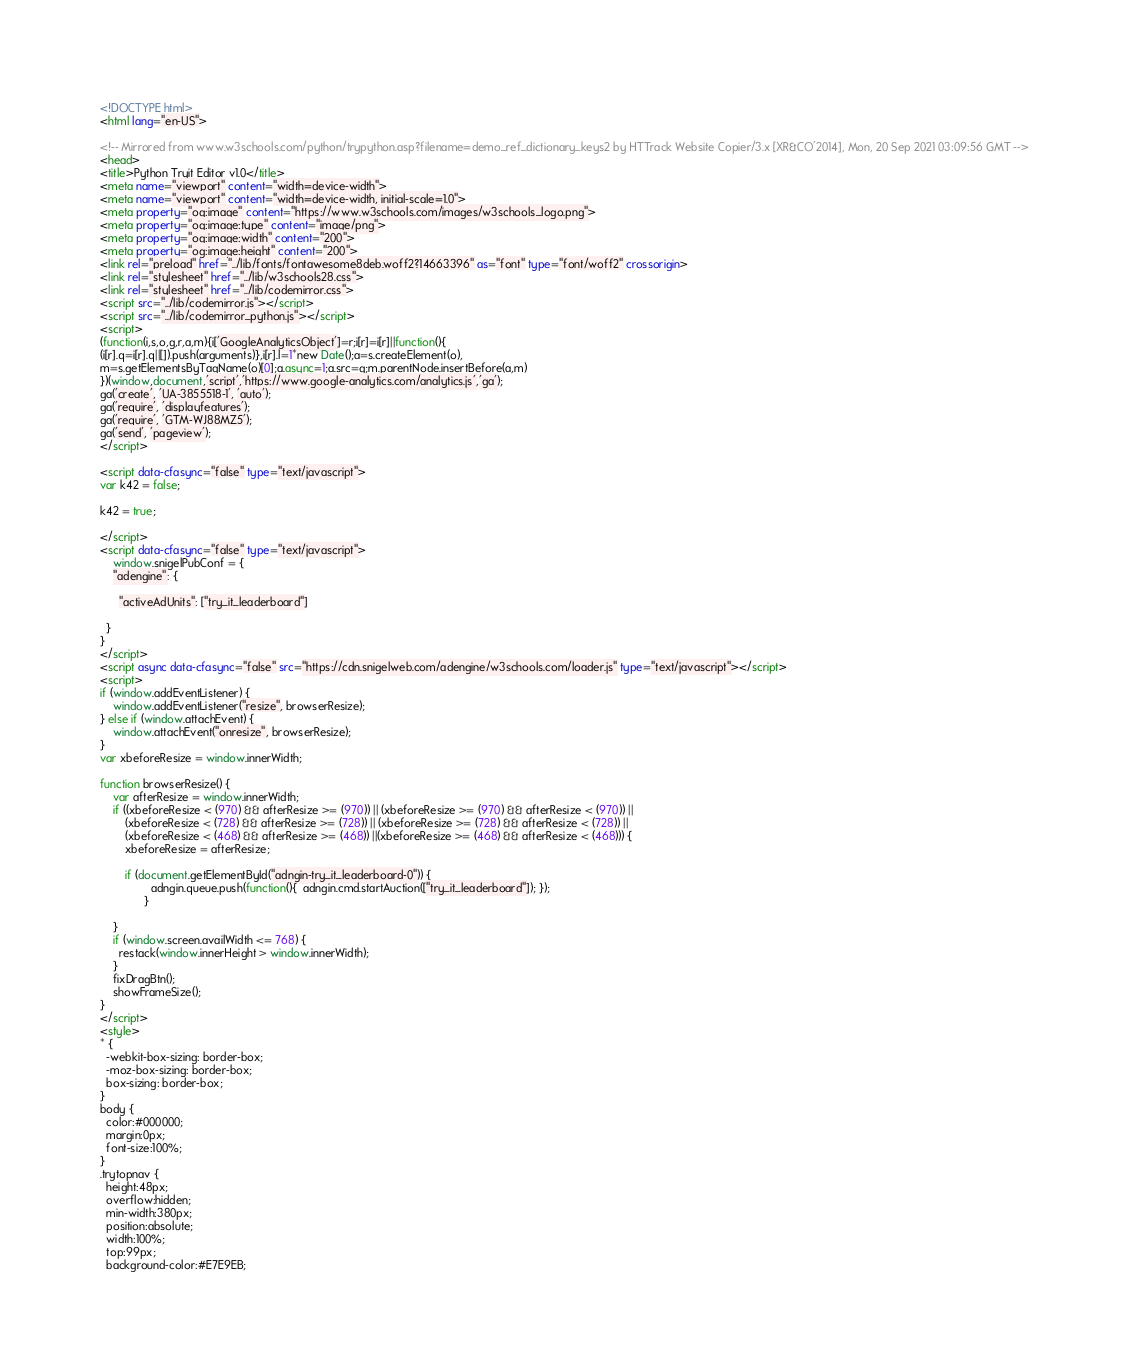Convert code to text. <code><loc_0><loc_0><loc_500><loc_500><_HTML_>
<!DOCTYPE html>
<html lang="en-US">

<!-- Mirrored from www.w3schools.com/python/trypython.asp?filename=demo_ref_dictionary_keys2 by HTTrack Website Copier/3.x [XR&CO'2014], Mon, 20 Sep 2021 03:09:56 GMT -->
<head>
<title>Python Tryit Editor v1.0</title>
<meta name="viewport" content="width=device-width">
<meta name="viewport" content="width=device-width, initial-scale=1.0">
<meta property="og:image" content="https://www.w3schools.com/images/w3schools_logo.png">
<meta property="og:image:type" content="image/png">
<meta property="og:image:width" content="200">
<meta property="og:image:height" content="200">
<link rel="preload" href="../lib/fonts/fontawesome8deb.woff2?14663396" as="font" type="font/woff2" crossorigin> 
<link rel="stylesheet" href="../lib/w3schools28.css">
<link rel="stylesheet" href="../lib/codemirror.css">
<script src="../lib/codemirror.js"></script>
<script src="../lib/codemirror_python.js"></script>
<script>
(function(i,s,o,g,r,a,m){i['GoogleAnalyticsObject']=r;i[r]=i[r]||function(){
(i[r].q=i[r].q||[]).push(arguments)},i[r].l=1*new Date();a=s.createElement(o),
m=s.getElementsByTagName(o)[0];a.async=1;a.src=g;m.parentNode.insertBefore(a,m)
})(window,document,'script','https://www.google-analytics.com/analytics.js','ga');
ga('create', 'UA-3855518-1', 'auto');
ga('require', 'displayfeatures');
ga('require', 'GTM-WJ88MZ5');
ga('send', 'pageview');
</script>

<script data-cfasync="false" type="text/javascript">
var k42 = false;

k42 = true;

</script>
<script data-cfasync="false" type="text/javascript">
    window.snigelPubConf = {
    "adengine": {

      "activeAdUnits": ["try_it_leaderboard"]

  }
}
</script>
<script async data-cfasync="false" src="https://cdn.snigelweb.com/adengine/w3schools.com/loader.js" type="text/javascript"></script>
<script>
if (window.addEventListener) {              
    window.addEventListener("resize", browserResize);
} else if (window.attachEvent) {                 
    window.attachEvent("onresize", browserResize);
}
var xbeforeResize = window.innerWidth;

function browserResize() {
    var afterResize = window.innerWidth;
    if ((xbeforeResize < (970) && afterResize >= (970)) || (xbeforeResize >= (970) && afterResize < (970)) ||
        (xbeforeResize < (728) && afterResize >= (728)) || (xbeforeResize >= (728) && afterResize < (728)) ||
        (xbeforeResize < (468) && afterResize >= (468)) ||(xbeforeResize >= (468) && afterResize < (468))) {
        xbeforeResize = afterResize;
        
        if (document.getElementById("adngin-try_it_leaderboard-0")) {
                adngin.queue.push(function(){  adngin.cmd.startAuction(["try_it_leaderboard"]); });
              }
         
    }
    if (window.screen.availWidth <= 768) {
      restack(window.innerHeight > window.innerWidth);
    }
    fixDragBtn();
    showFrameSize();    
}
</script>
<style>
* {
  -webkit-box-sizing: border-box;
  -moz-box-sizing: border-box;
  box-sizing: border-box;
}
body {
  color:#000000;
  margin:0px;
  font-size:100%;
}
.trytopnav {
  height:48px;
  overflow:hidden;
  min-width:380px;
  position:absolute;
  width:100%;
  top:99px;
  background-color:#E7E9EB;</code> 